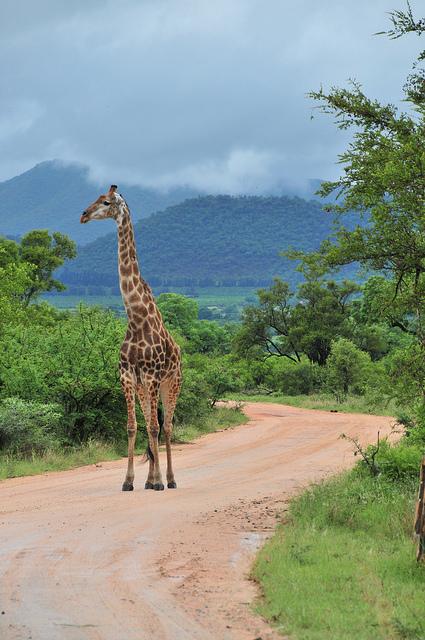How old is the giraffe?
Short answer required. 4 years. Is this in a zoo?
Short answer required. No. What is behind the animal?
Be succinct. Trees. Where is this?
Be succinct. Africa. Is this giraffe out in the wild?
Give a very brief answer. Yes. Does this animal eat meat?
Concise answer only. No. Are the giraffes in a zoo?
Be succinct. No. Are the giraffes in the wild?
Write a very short answer. Yes. Is this in the wild or zoo?
Concise answer only. Wild. Which way is the giraffe facing?
Quick response, please. Left. What type of scene is this?
Quick response, please. Nature. Is this in the wild?
Quick response, please. Yes. Is it sunny?
Be succinct. No. Is it sunny out?
Be succinct. Yes. Is there a fence?
Short answer required. No. What is the animal standing on?
Answer briefly. Road. Are there mountains in the background?
Keep it brief. Yes. Is there more than one giraffe?
Write a very short answer. No. Is there a paved road in the picture?
Short answer required. No. Is the giraffe contained?
Answer briefly. No. What is the giraffe doing?
Concise answer only. Standing. Which giraffe is the youngest?
Give a very brief answer. Only 1. What is in front of the Giraffe?
Write a very short answer. Road. Was this picture taken at a zoo?
Concise answer only. No. 